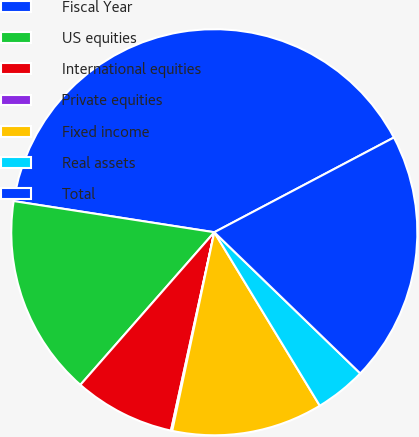Convert chart. <chart><loc_0><loc_0><loc_500><loc_500><pie_chart><fcel>Fiscal Year<fcel>US equities<fcel>International equities<fcel>Private equities<fcel>Fixed income<fcel>Real assets<fcel>Total<nl><fcel>39.82%<fcel>15.99%<fcel>8.04%<fcel>0.1%<fcel>12.02%<fcel>4.07%<fcel>19.96%<nl></chart> 